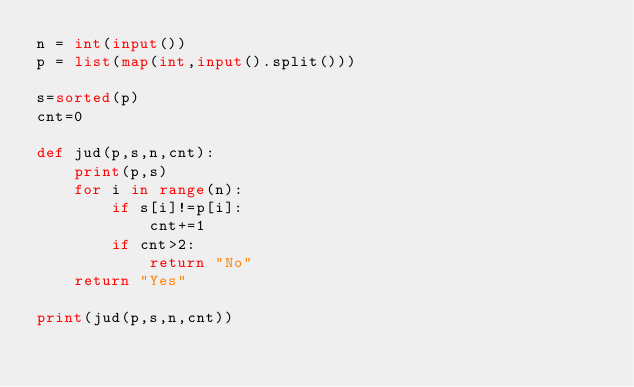Convert code to text. <code><loc_0><loc_0><loc_500><loc_500><_Python_>n = int(input())
p = list(map(int,input().split()))

s=sorted(p)
cnt=0

def jud(p,s,n,cnt):
    print(p,s)
    for i in range(n):
        if s[i]!=p[i]:
            cnt+=1
        if cnt>2:
            return "No"
    return "Yes"

print(jud(p,s,n,cnt))</code> 